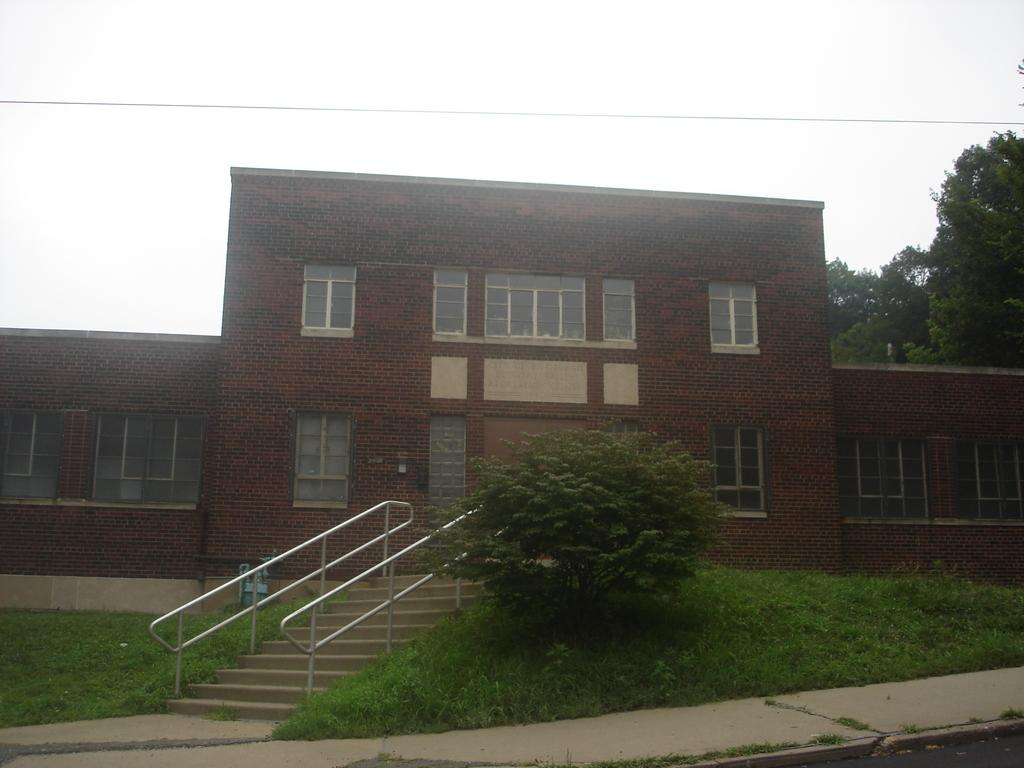What type of vegetation is on the left side of the image? A: There is grass on the left side of the image. What structure is located in the middle of the image? There is a house in the middle of the image. What type of natural feature is on the back side of the image? There are trees on the back side of the image. What type of lace can be seen hanging from the trees in the image? There is no lace present in the trees in the image; only grass, a house, and trees are visible. Is there a cave visible in the image? There is no cave present in the image. 